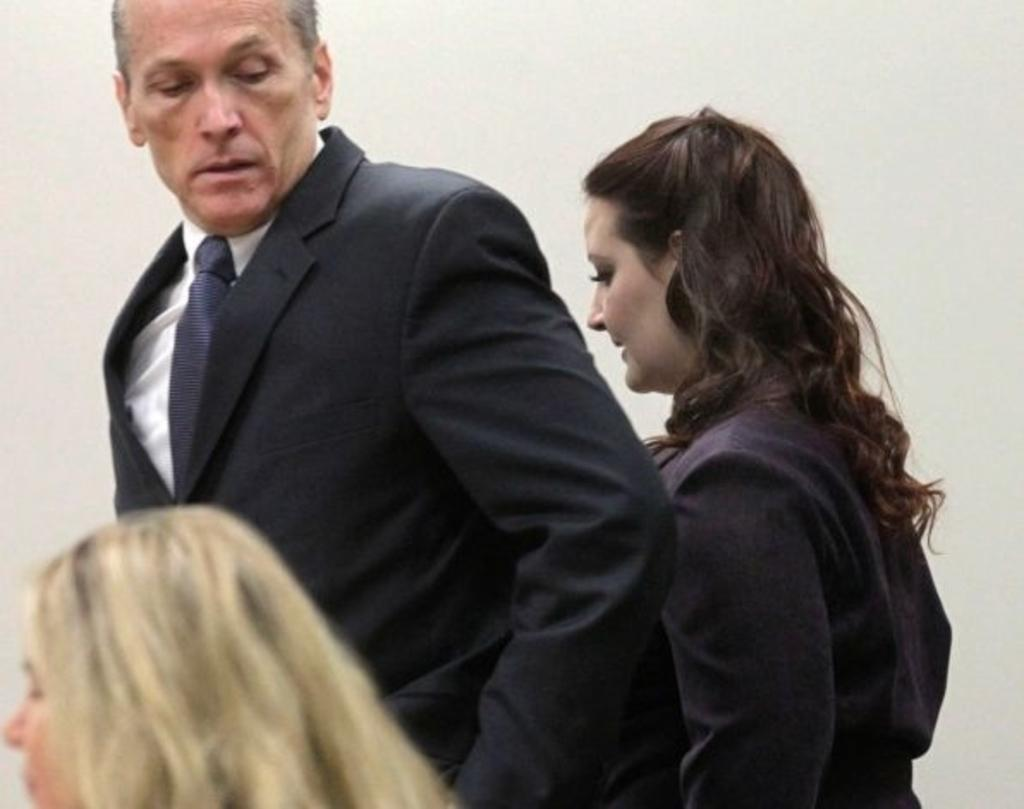What is the main subject of the image? The main subject of the image is the persons in the center of the image. What can be seen in the background of the image? There is a wall in the background of the image. Can you tell me how many tigers are present in the image? There are no tigers present in the image. What type of question is being asked in the image? There is no question being asked in the image; it is a visual representation of the persons and the wall. 